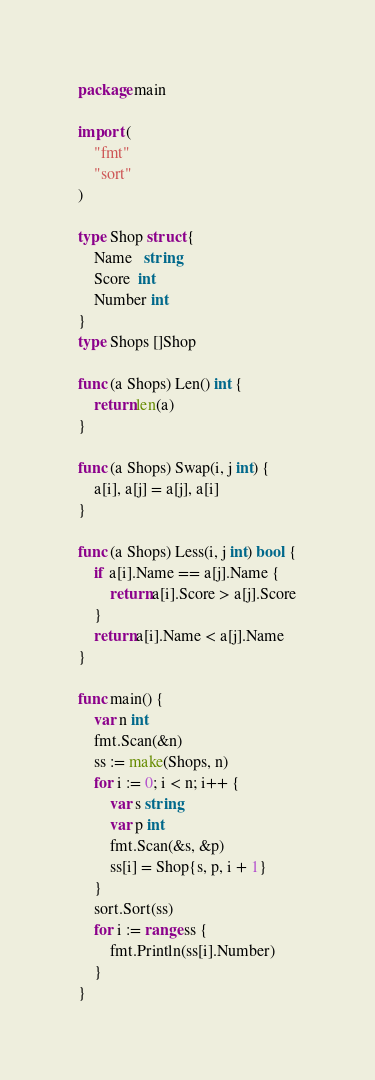<code> <loc_0><loc_0><loc_500><loc_500><_Go_>package main
  
import (
    "fmt"
    "sort"
)

type Shop struct {
    Name   string
    Score  int
    Number int
}
type Shops []Shop

func (a Shops) Len() int {
    return len(a)
}

func (a Shops) Swap(i, j int) {
    a[i], a[j] = a[j], a[i]
}

func (a Shops) Less(i, j int) bool {
    if a[i].Name == a[j].Name {
        return a[i].Score > a[j].Score
    }
    return a[i].Name < a[j].Name
}

func main() {
    var n int
    fmt.Scan(&n)
    ss := make(Shops, n)
    for i := 0; i < n; i++ {
        var s string
        var p int
        fmt.Scan(&s, &p)
        ss[i] = Shop{s, p, i + 1}
    }
    sort.Sort(ss)
    for i := range ss {
        fmt.Println(ss[i].Number)
    }
}
</code> 